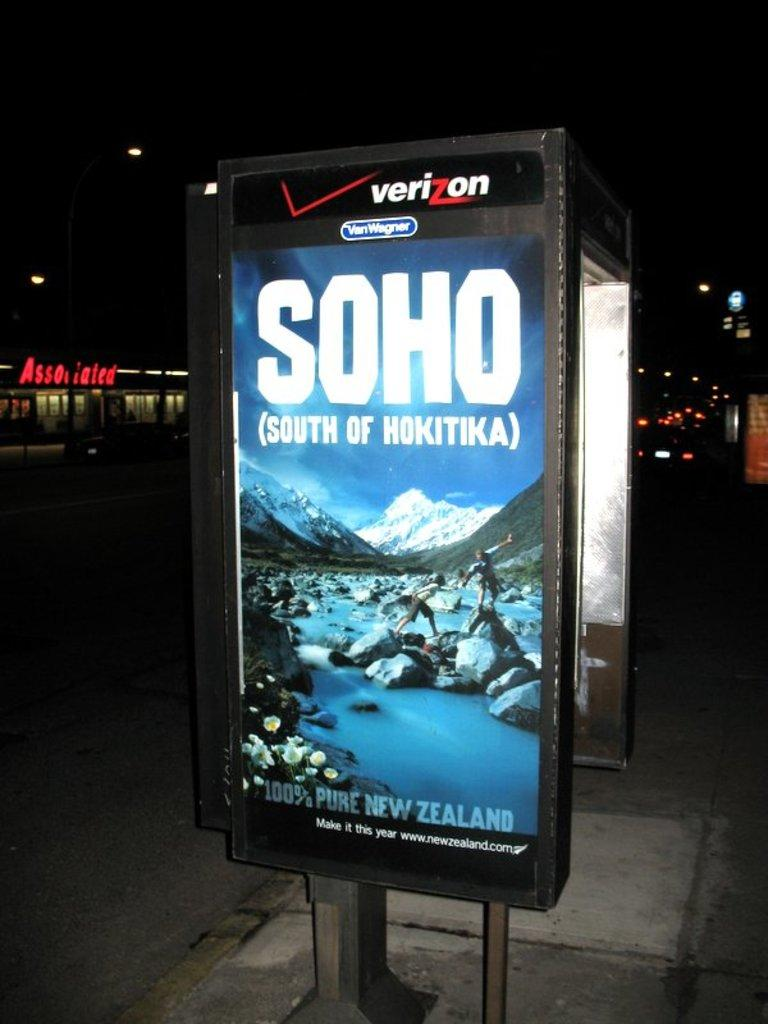<image>
Create a compact narrative representing the image presented. A Verizon billboard with the advertisement Soho 100% pure New Zealand. 